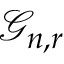Convert formula to latex. <formula><loc_0><loc_0><loc_500><loc_500>{ \mathcal { G } } _ { n , r }</formula> 